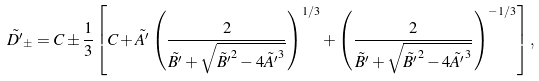Convert formula to latex. <formula><loc_0><loc_0><loc_500><loc_500>\tilde { D ^ { \prime } } _ { \pm } = C \pm \frac { 1 } { 3 } \left [ C + \tilde { A ^ { \prime } } \left ( \frac { 2 } { \tilde { B ^ { \prime } } + \sqrt { \tilde { B ^ { \prime } } ^ { 2 } - 4 \tilde { A ^ { \prime } } ^ { 3 } } } \right ) ^ { 1 / 3 } + \left ( \frac { 2 } { \tilde { B ^ { \prime } } + \sqrt { \tilde { B ^ { \prime } } ^ { 2 } - 4 \tilde { A ^ { \prime } } ^ { 3 } } } \right ) ^ { - 1 / 3 } \right ] ,</formula> 